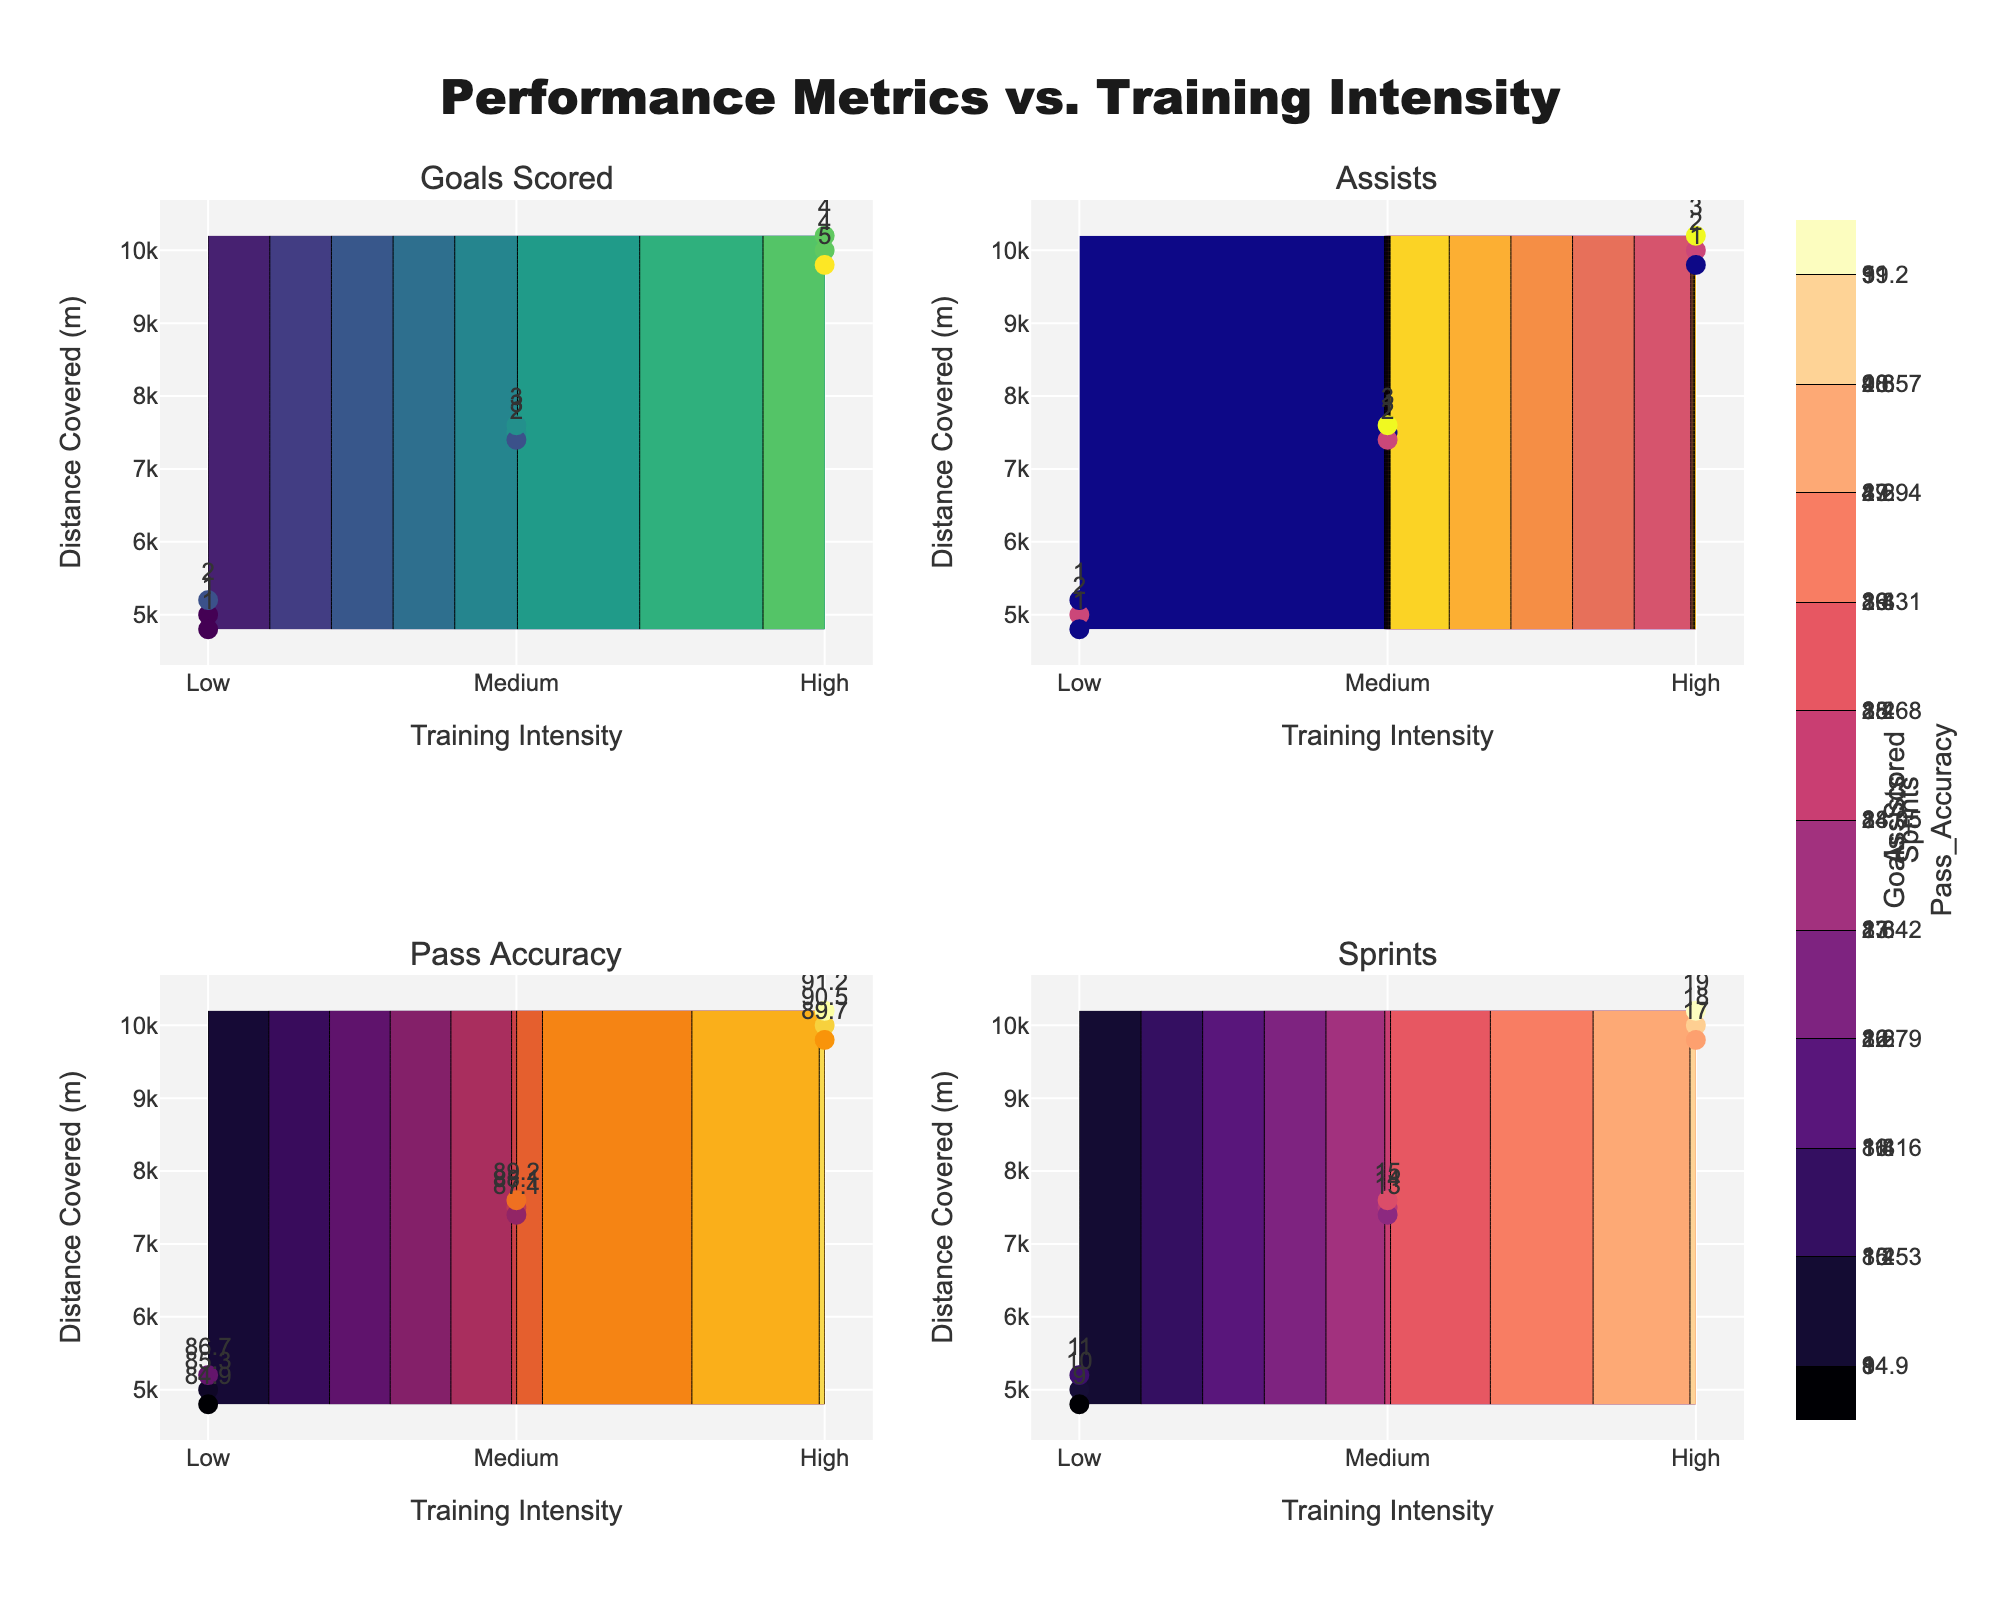How many categories of training intensity are displayed in the figure? The x-axis of the plot represents the training intensity and it is divided into three categories: Low, Medium, and High.
Answer: 3 Which performance metric shows the highest value at the highest training intensity level? To determine this, we observe the contour plots and the metrics' values at the highest training intensity (High). The highest values of each metric at High intensity are as follows: Goals Scored - 5, Assists - 3, Pass Accuracy - 91.2, Sprints - 19. Among these, Pass Accuracy is the highest.
Answer: Pass Accuracy For the medium training intensity, what is the range of distance covered observed in the figure? By referring to the data points plotted for medium training intensity, the smallest value is 7400 meters, and the largest value observed is 7600 meters.
Answer: 7400 to 7600 meters Which metric has the most significant increase in value from low to high training intensity? We need to compare the values of each metric at Low and High intensity levels and evaluate the increase.
- Goals Scored: Low (1-2) to High (4-5) => Increase of 3
- Assists: Low (1-2) to High (1-3) => Increase of 1
- Pass Accuracy: Low (84.9-86.7) to High (89.7-91.2) => Increase of about 6.3
- Sprints: Low (9-11) to High (17-19) => Increase of about 8
Sprints show the most significant increase.
Answer: Sprints How does the number of goals scored change as the distance covered increases for medium intensity training? By looking at the scatter plots for Goals Scored at medium intensity, it is evident that as the distance covered increases (from 7400 to 7600 meters), the number of goals increases from 2 to 3.
Answer: Increase In which section of the plot is the range of pass accuracy the smallest for any given intensity level? By examining the contour plot for Pass Accuracy, we can see that the range for Low intensity (approximately 84.9 to 86.7) is smaller compared to Medium and High intensities.
Answer: Low intensity Compare the assist counts for High and Medium training intensities. Which one has a higher maximum count, and by how much? The highest values for assists are 3 at both High and Medium intensity levels.
Answer: Equal What is the average number of sprints completed at high intensity? For High intensity, the sprint counts are 18, 17, and 19. The sum is 54, and there are 3 data points. The average is 54/3.
Answer: 18 Looking at the entire plot, which training intensity and performance metric combination has the lowest value? To find the lowest value, we look at all metrics for all intensity levels. The lowest value is in Assists for Low intensity, which is 1.
Answer: Assists at Low intensity How does training intensity correlate with goals scored based on the provided data points? Observing the scatter plot for Goals Scored, as training intensity increases from Low to High, the number of goals scored increases. The correlation appears to be positive.
Answer: Positively 